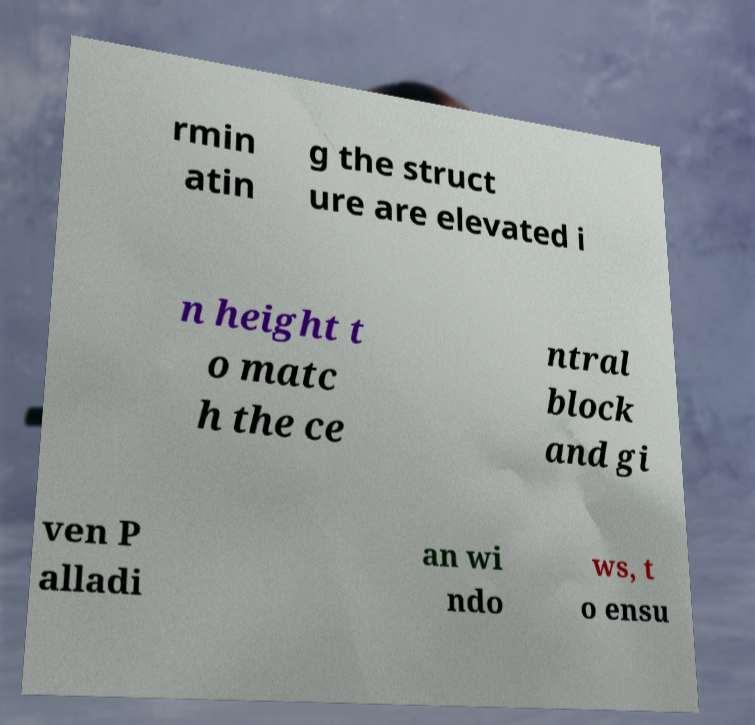There's text embedded in this image that I need extracted. Can you transcribe it verbatim? rmin atin g the struct ure are elevated i n height t o matc h the ce ntral block and gi ven P alladi an wi ndo ws, t o ensu 